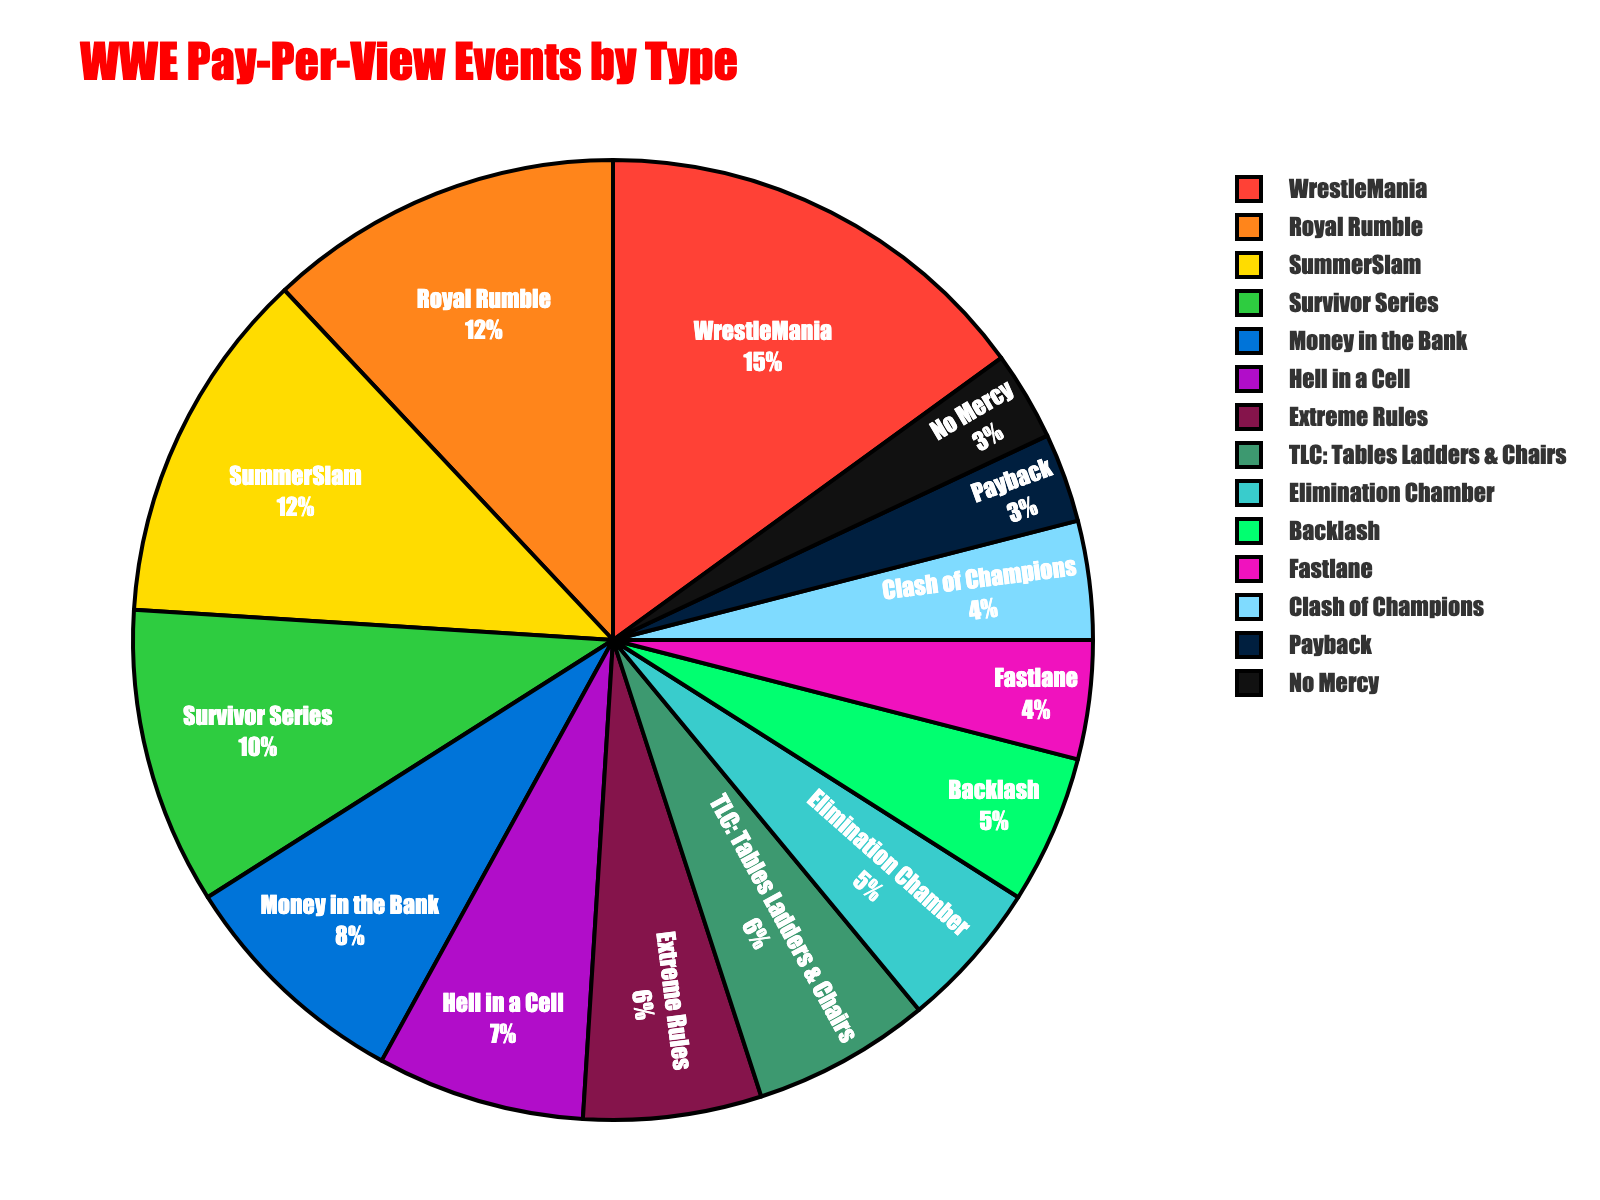What's the event type with the highest percentage? The event type with the highest percentage in the pie chart is indicated by the largest slice. WrestleMania has the highest percentage.
Answer: WrestleMania Which two event types have the same percentage and what is that percentage? In the pie chart, two slices have the same size which suggests their percentages are equal. Royal Rumble and SummerSlam both have a percentage of 12%.
Answer: Royal Rumble, SummerSlam, 12% What is the combined percentage of WrestleMania and Survivor Series? To find the combined percentage, sum the individual percentages of WrestleMania (15%) and Survivor Series (10%). 15% + 10% = 25%.
Answer: 25% Which event type occupies the smallest slice in the pie chart? The smallest slice in the pie chart represents the event type with the smallest percentage. No Mercy and Payback both occupy the smallest slice with 3%.
Answer: No Mercy, Payback Does Hell in a Cell have a greater percentage than TLC: Tables Ladders & Chairs? Compare the slices for Hell in a Cell and TLC: Tables Ladders & Chairs. Hell in a Cell has 7% while TLC has 6%, so Hell in a Cell has a greater percentage.
Answer: Yes How many event types have a percentage higher than 10%? Identify all event types with percentages higher than 10%. WrestleMania (15%), Royal Rumble (12%), and SummerSlam (12%) meet this criteria. There are 3 event types.
Answer: 3 What's the average percentage of Hell in a Cell, Extreme Rules, and Elimination Chamber? To find the average, sum the percentages of these events and divide by the number of events. (7% + 6% + 5%) / 3 = 18% / 3 = 6%.
Answer: 6% What's the difference in percentage between Fastlane and Money in the Bank? Calculate the difference by subtracting the percentage of Fastlane (4%) from Money in the Bank (8%). 8% - 4% = 4%.
Answer: 4% Which event has a higher percentage: Backlash or Clash of Champions? Compare the percentages of these two events. Both Backlash and Clash of Champions have a percentage of 5% and 4% respectively. Backlash has a higher percentage.
Answer: Backlash What is the total percentage of events that belong to the Top 4 highest percentages? Sum the percentages of the top 4 events: WrestleMania (15%), Royal Rumble (12%), SummerSlam (12%), and Survivor Series (10%). 15% + 12% + 12% + 10% = 49%.
Answer: 49% 